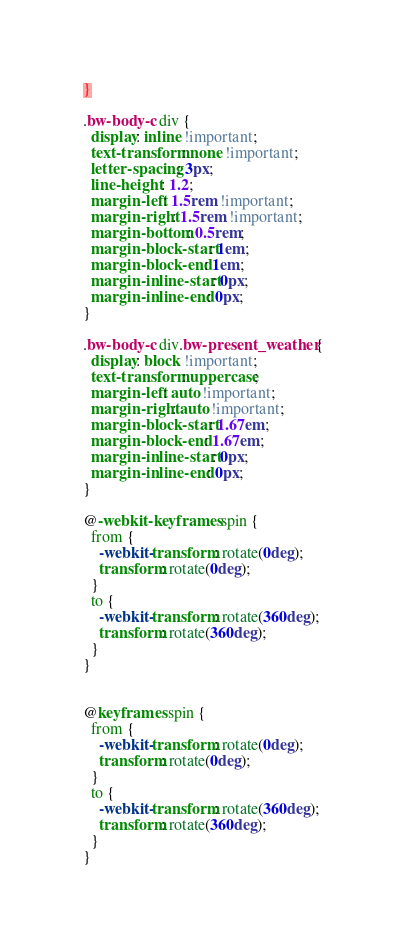<code> <loc_0><loc_0><loc_500><loc_500><_CSS_>}

.bw-body-c div {
  display: inline !important;
  text-transform: none !important;
  letter-spacing: 3px;
  line-height: 1.2;
  margin-left: 1.5rem !important;
  margin-right: 1.5rem !important;
  margin-bottom: 0.5rem;
  margin-block-start: 1em;
  margin-block-end: 1em;
  margin-inline-start: 0px;
  margin-inline-end: 0px;
}

.bw-body-c div.bw-present_weather {
  display: block !important;
  text-transform: uppercase;
  margin-left: auto !important;
  margin-right: auto !important;
  margin-block-start: 1.67em;
  margin-block-end: 1.67em;
  margin-inline-start: 0px;
  margin-inline-end: 0px;
}

@-webkit-keyframes spin {
  from {
    -webkit-transform: rotate(0deg);
    transform: rotate(0deg);
  }
  to {
    -webkit-transform: rotate(360deg);
    transform: rotate(360deg);
  }
}


@keyframes spin {
  from {
    -webkit-transform: rotate(0deg);
    transform: rotate(0deg);
  }
  to {
    -webkit-transform: rotate(360deg);
    transform: rotate(360deg);
  }
}</code> 